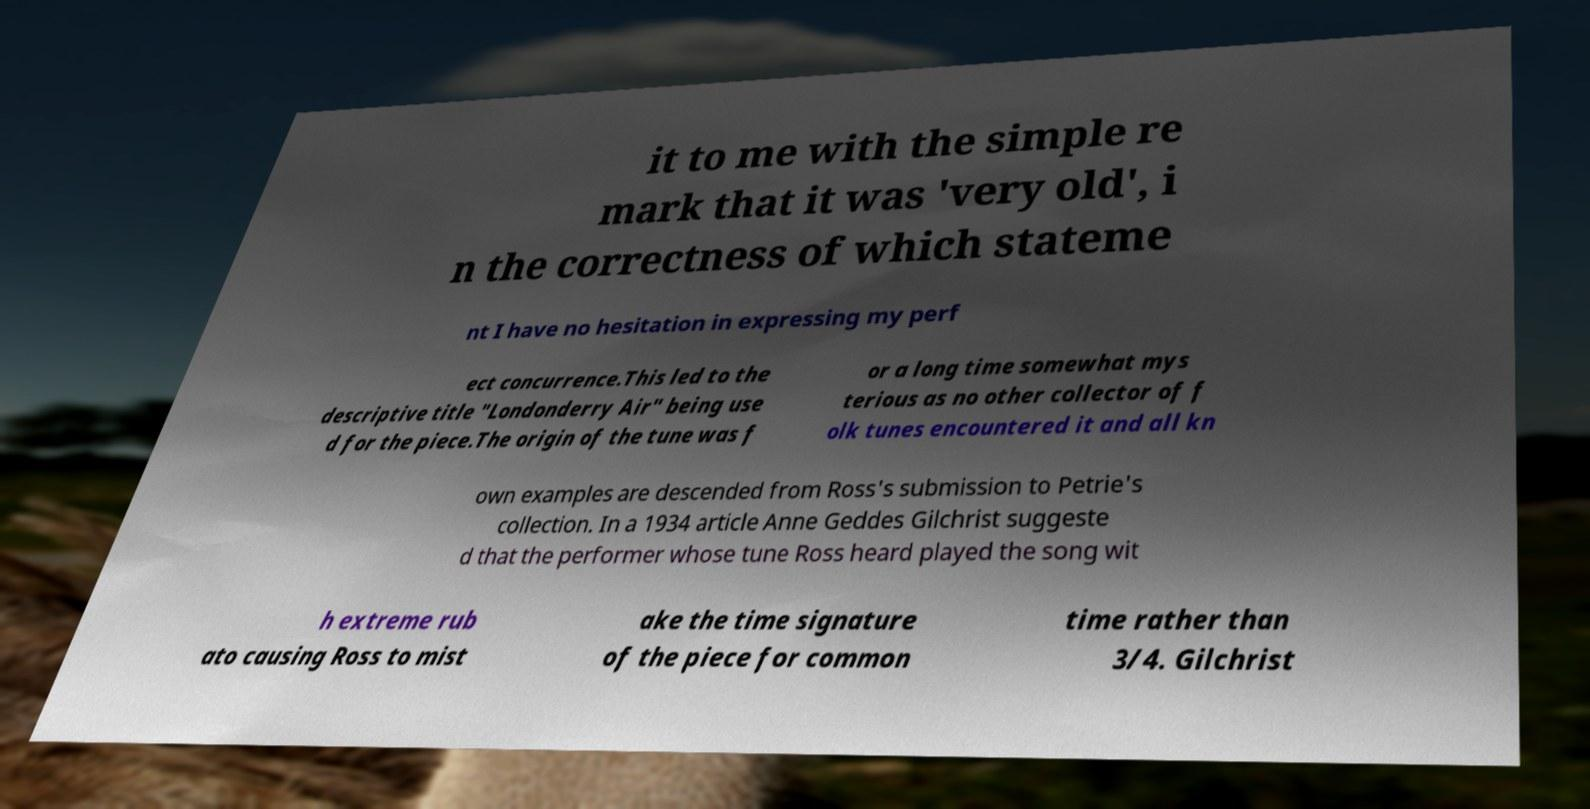Could you extract and type out the text from this image? it to me with the simple re mark that it was 'very old', i n the correctness of which stateme nt I have no hesitation in expressing my perf ect concurrence.This led to the descriptive title "Londonderry Air" being use d for the piece.The origin of the tune was f or a long time somewhat mys terious as no other collector of f olk tunes encountered it and all kn own examples are descended from Ross's submission to Petrie's collection. In a 1934 article Anne Geddes Gilchrist suggeste d that the performer whose tune Ross heard played the song wit h extreme rub ato causing Ross to mist ake the time signature of the piece for common time rather than 3/4. Gilchrist 